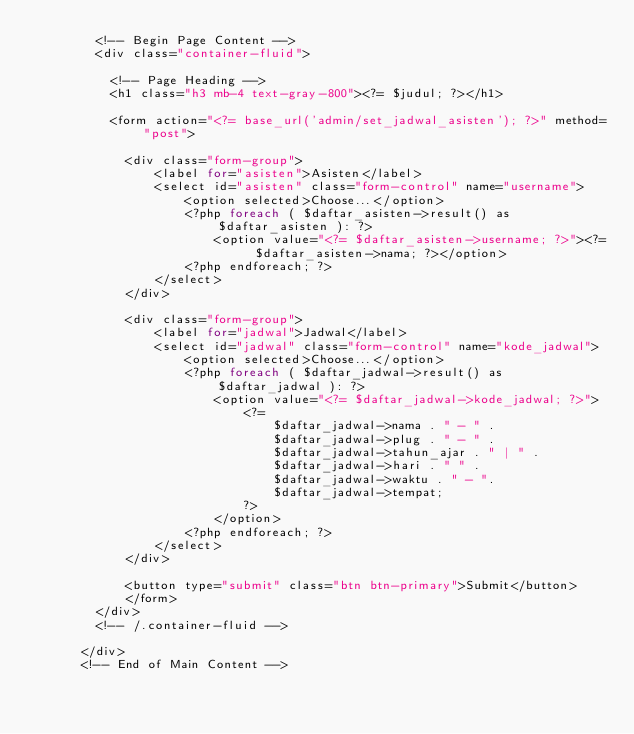Convert code to text. <code><loc_0><loc_0><loc_500><loc_500><_PHP_>        <!-- Begin Page Content -->
        <div class="container-fluid">

          <!-- Page Heading -->
          <h1 class="h3 mb-4 text-gray-800"><?= $judul; ?></h1>

          <form action="<?= base_url('admin/set_jadwal_asisten'); ?>" method="post">

            <div class="form-group">
                <label for="asisten">Asisten</label>
                <select id="asisten" class="form-control" name="username">
                    <option selected>Choose...</option>
                    <?php foreach ( $daftar_asisten->result() as $daftar_asisten ): ?>
                        <option value="<?= $daftar_asisten->username; ?>"><?= $daftar_asisten->nama; ?></option>
                    <?php endforeach; ?>
                </select>
            </div>

            <div class="form-group">
                <label for="jadwal">Jadwal</label>
                <select id="jadwal" class="form-control" name="kode_jadwal">
                    <option selected>Choose...</option>
                    <?php foreach ( $daftar_jadwal->result() as $daftar_jadwal ): ?>
                        <option value="<?= $daftar_jadwal->kode_jadwal; ?>">
                            <?= 
                                $daftar_jadwal->nama . " - " . 
                                $daftar_jadwal->plug . " - " .
                                $daftar_jadwal->tahun_ajar . " | " .
                                $daftar_jadwal->hari . " " .
                                $daftar_jadwal->waktu . " - ".
                                $daftar_jadwal->tempat; 
                            ?>
                        </option>
                    <?php endforeach; ?>
                </select>
            </div>

            <button type="submit" class="btn btn-primary">Submit</button>
            </form>
        </div>
        <!-- /.container-fluid -->

      </div>
      <!-- End of Main Content --></code> 